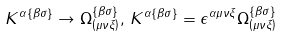Convert formula to latex. <formula><loc_0><loc_0><loc_500><loc_500>K ^ { \alpha \left \{ \beta \sigma \right \} } \rightarrow \Omega _ { \left ( \mu \nu \xi \right ) } ^ { \left \{ \beta \sigma \right \} } , \, K ^ { \alpha \left \{ \beta \sigma \right \} } = \epsilon ^ { \alpha \mu \nu \xi } \Omega _ { \left ( \mu \nu \xi \right ) } ^ { \left \{ \beta \sigma \right \} }</formula> 